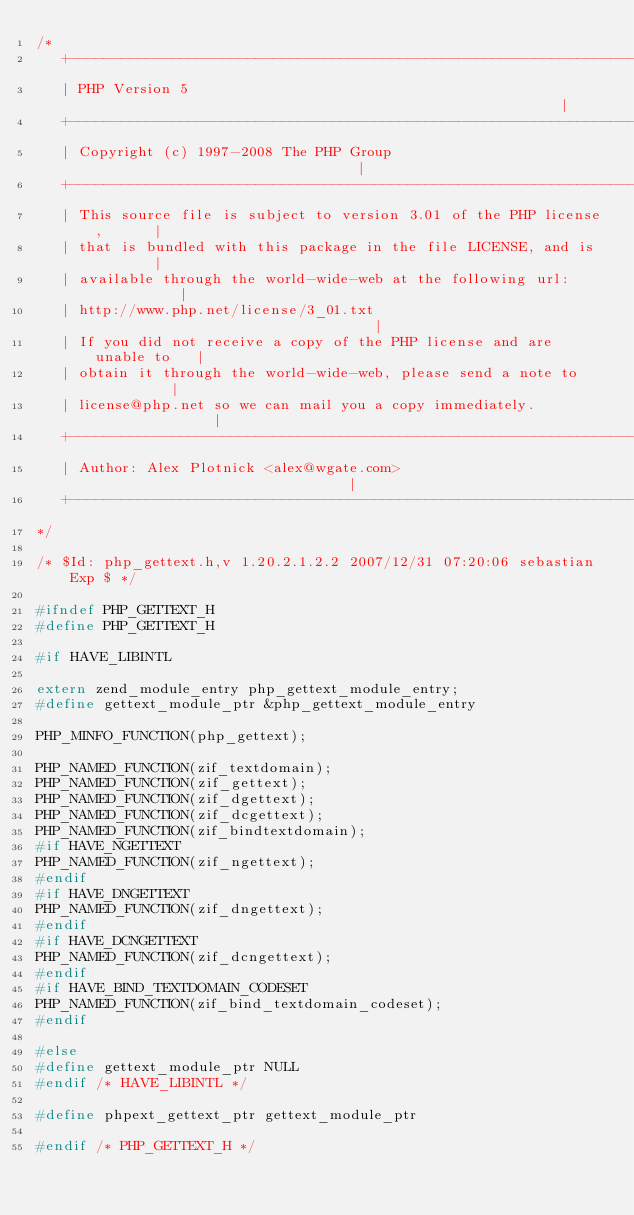<code> <loc_0><loc_0><loc_500><loc_500><_C_>/*
   +----------------------------------------------------------------------+
   | PHP Version 5                                                        |
   +----------------------------------------------------------------------+
   | Copyright (c) 1997-2008 The PHP Group                                |
   +----------------------------------------------------------------------+
   | This source file is subject to version 3.01 of the PHP license,      |
   | that is bundled with this package in the file LICENSE, and is        |
   | available through the world-wide-web at the following url:           |
   | http://www.php.net/license/3_01.txt                                  |
   | If you did not receive a copy of the PHP license and are unable to   |
   | obtain it through the world-wide-web, please send a note to          |
   | license@php.net so we can mail you a copy immediately.               |
   +----------------------------------------------------------------------+
   | Author: Alex Plotnick <alex@wgate.com>                               |
   +----------------------------------------------------------------------+
*/

/* $Id: php_gettext.h,v 1.20.2.1.2.2 2007/12/31 07:20:06 sebastian Exp $ */

#ifndef PHP_GETTEXT_H
#define PHP_GETTEXT_H

#if HAVE_LIBINTL

extern zend_module_entry php_gettext_module_entry;
#define gettext_module_ptr &php_gettext_module_entry

PHP_MINFO_FUNCTION(php_gettext);

PHP_NAMED_FUNCTION(zif_textdomain);
PHP_NAMED_FUNCTION(zif_gettext);
PHP_NAMED_FUNCTION(zif_dgettext);
PHP_NAMED_FUNCTION(zif_dcgettext);
PHP_NAMED_FUNCTION(zif_bindtextdomain);
#if HAVE_NGETTEXT
PHP_NAMED_FUNCTION(zif_ngettext);
#endif
#if HAVE_DNGETTEXT
PHP_NAMED_FUNCTION(zif_dngettext);
#endif
#if HAVE_DCNGETTEXT
PHP_NAMED_FUNCTION(zif_dcngettext);
#endif
#if HAVE_BIND_TEXTDOMAIN_CODESET
PHP_NAMED_FUNCTION(zif_bind_textdomain_codeset);
#endif

#else
#define gettext_module_ptr NULL
#endif /* HAVE_LIBINTL */

#define phpext_gettext_ptr gettext_module_ptr

#endif /* PHP_GETTEXT_H */
</code> 